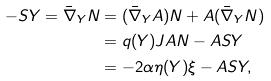Convert formula to latex. <formula><loc_0><loc_0><loc_500><loc_500>- S Y = { \bar { \nabla } } _ { Y } N & = ( { \bar { \nabla } } _ { Y } A ) N + A ( { \bar { \nabla } } _ { Y } N ) \\ & = q ( Y ) J A N - A S Y \\ & = - 2 \alpha \eta ( Y ) \xi - A S Y ,</formula> 